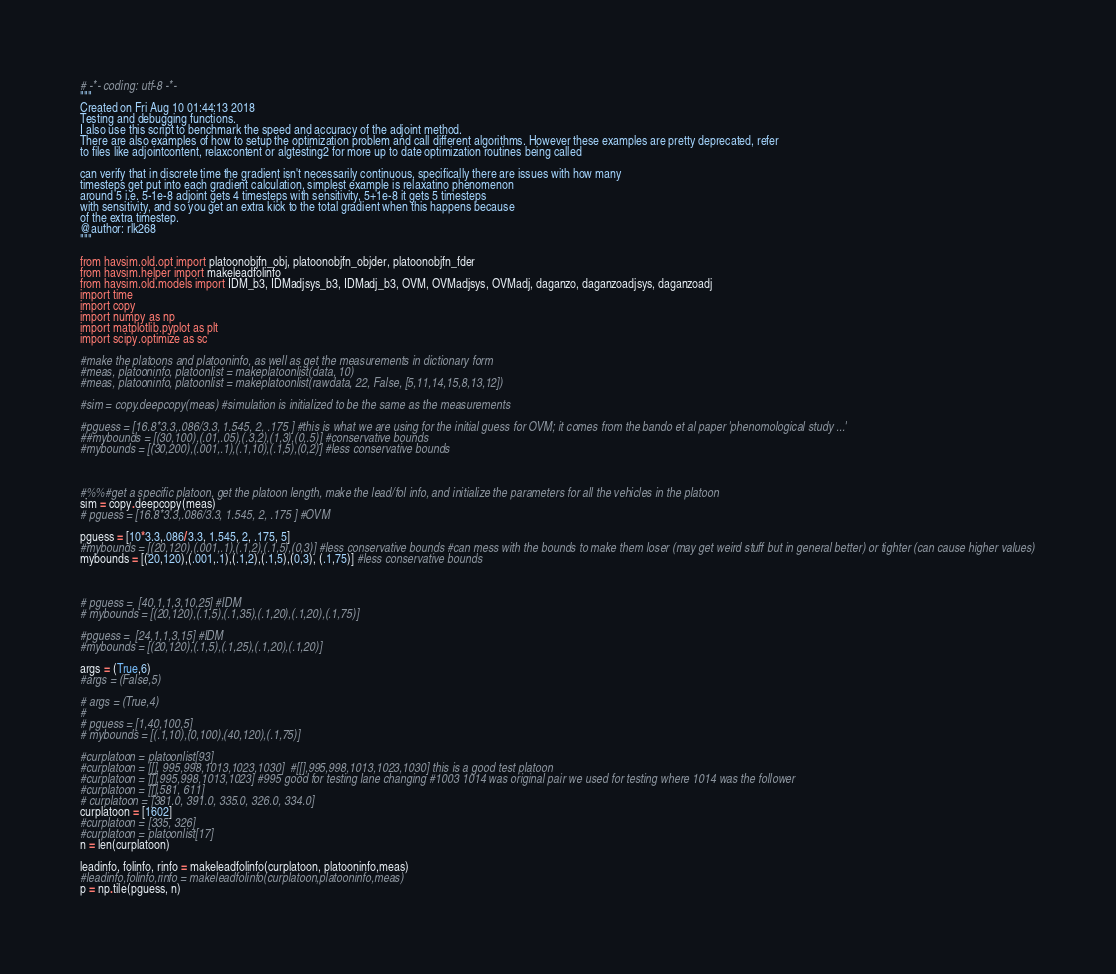Convert code to text. <code><loc_0><loc_0><loc_500><loc_500><_Python_># -*- coding: utf-8 -*-
"""
Created on Fri Aug 10 01:44:13 2018
Testing and debugging functions.
I also use this script to benchmark the speed and accuracy of the adjoint method.
There are also examples of how to setup the optimization problem and call different algorithms. However these examples are pretty deprecated, refer
to files like adjointcontent, relaxcontent or algtesting2 for more up to date optimization routines being called

can verify that in discrete time the gradient isn't necessarily continuous, specifically there are issues with how many
timesteps get put into each gradient calculation, simplest example is relaxatino phenomenon
around 5 i.e. 5-1e-8 adjoint gets 4 timesteps with sensitivity, 5+1e-8 it gets 5 timesteps
with sensitivity, and so you get an extra kick to the total gradient when this happens because
of the extra timestep.
@author: rlk268
"""

from havsim.old.opt import platoonobjfn_obj, platoonobjfn_objder, platoonobjfn_fder
from havsim.helper import makeleadfolinfo
from havsim.old.models import IDM_b3, IDMadjsys_b3, IDMadj_b3, OVM, OVMadjsys, OVMadj, daganzo, daganzoadjsys, daganzoadj
import time
import copy
import numpy as np
import matplotlib.pyplot as plt
import scipy.optimize as sc

#make the platoons and platooninfo, as well as get the measurements in dictionary form
#meas, platooninfo, platoonlist = makeplatoonlist(data, 10)
#meas, platooninfo, platoonlist = makeplatoonlist(rawdata, 22, False, [5,11,14,15,8,13,12])

#sim = copy.deepcopy(meas) #simulation is initialized to be the same as the measurements

#pguess = [16.8*3.3,.086/3.3, 1.545, 2, .175 ] #this is what we are using for the initial guess for OVM; it comes from the bando et al paper 'phenomological study ...'
##mybounds = [(30,100),(.01,.05),(.3,2),(1,3),(0,.5)] #conservative bounds
#mybounds = [(30,200),(.001,.1),(.1,10),(.1,5),(0,2)] #less conservative bounds



#%%#get a specific platoon, get the platoon length, make the lead/fol info, and initialize the parameters for all the vehicles in the platoon
sim = copy.deepcopy(meas)
# pguess = [16.8*3.3,.086/3.3, 1.545, 2, .175 ] #OVM

pguess = [10*3.3,.086/3.3, 1.545, 2, .175, 5]
#mybounds = [(20,120),(.001,.1),(.1,2),(.1,5),(0,3)] #less conservative bounds #can mess with the bounds to make them loser (may get weird stuff but in general better) or tighter (can cause higher values)
mybounds = [(20,120),(.001,.1),(.1,2),(.1,5),(0,3), (.1,75)] #less conservative bounds



# pguess =  [40,1,1,3,10,25] #IDM
# mybounds = [(20,120),(.1,5),(.1,35),(.1,20),(.1,20),(.1,75)]

#pguess =  [24,1,1,3,15] #IDM
#mybounds = [(20,120),(.1,5),(.1,25),(.1,20),(.1,20)]

args = (True,6)
#args = (False,5)

# args = (True,4)
#
# pguess = [1,40,100,5]
# mybounds = [(.1,10),(0,100),(40,120),(.1,75)]

#curplatoon = platoonlist[93]
#curplatoon = [[], 995,998,1013,1023,1030]  #[[],995,998,1013,1023,1030] this is a good test platoon
#curplatoon = [[],995,998,1013,1023] #995 good for testing lane changing #1003 1014 was original pair we used for testing where 1014 was the follower
#curplatoon = [[],581, 611]
# curplatoon = [381.0, 391.0, 335.0, 326.0, 334.0]
curplatoon = [1602]
#curplatoon = [335, 326]
#curplatoon = platoonlist[17]
n = len(curplatoon)

leadinfo, folinfo, rinfo = makeleadfolinfo(curplatoon, platooninfo,meas)
#leadinfo,folinfo,rinfo = makeleadfolinfo(curplatoon,platooninfo,meas)
p = np.tile(pguess, n)</code> 